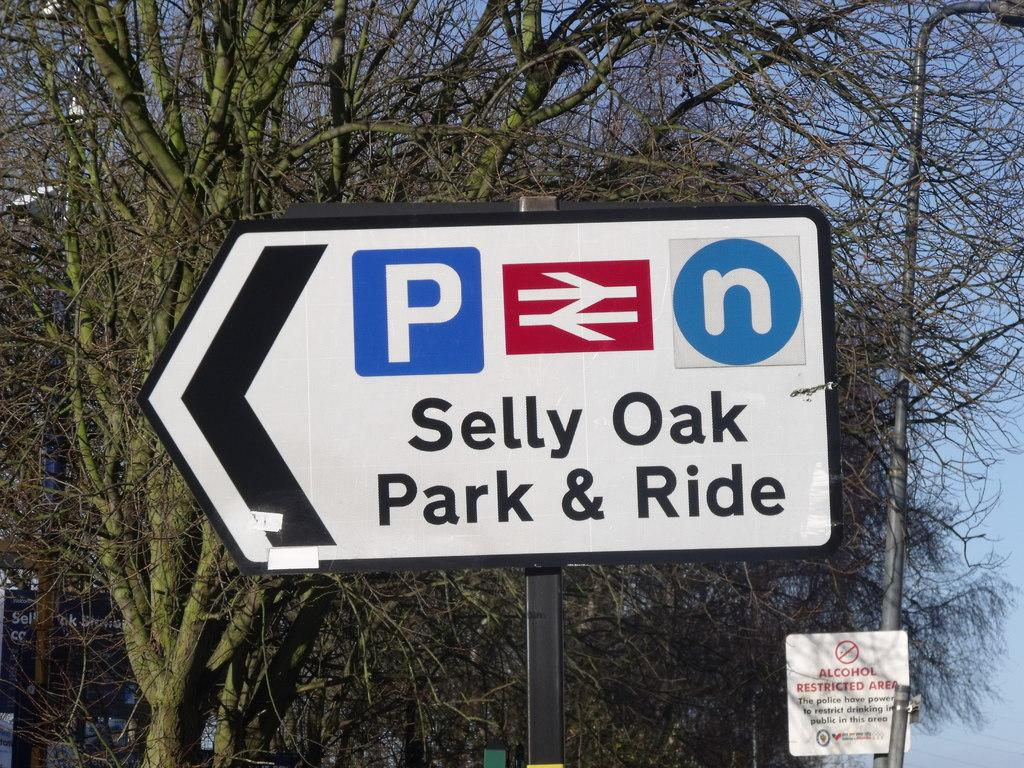<image>
Write a terse but informative summary of the picture. Selly Oak park and ride is to the left. 